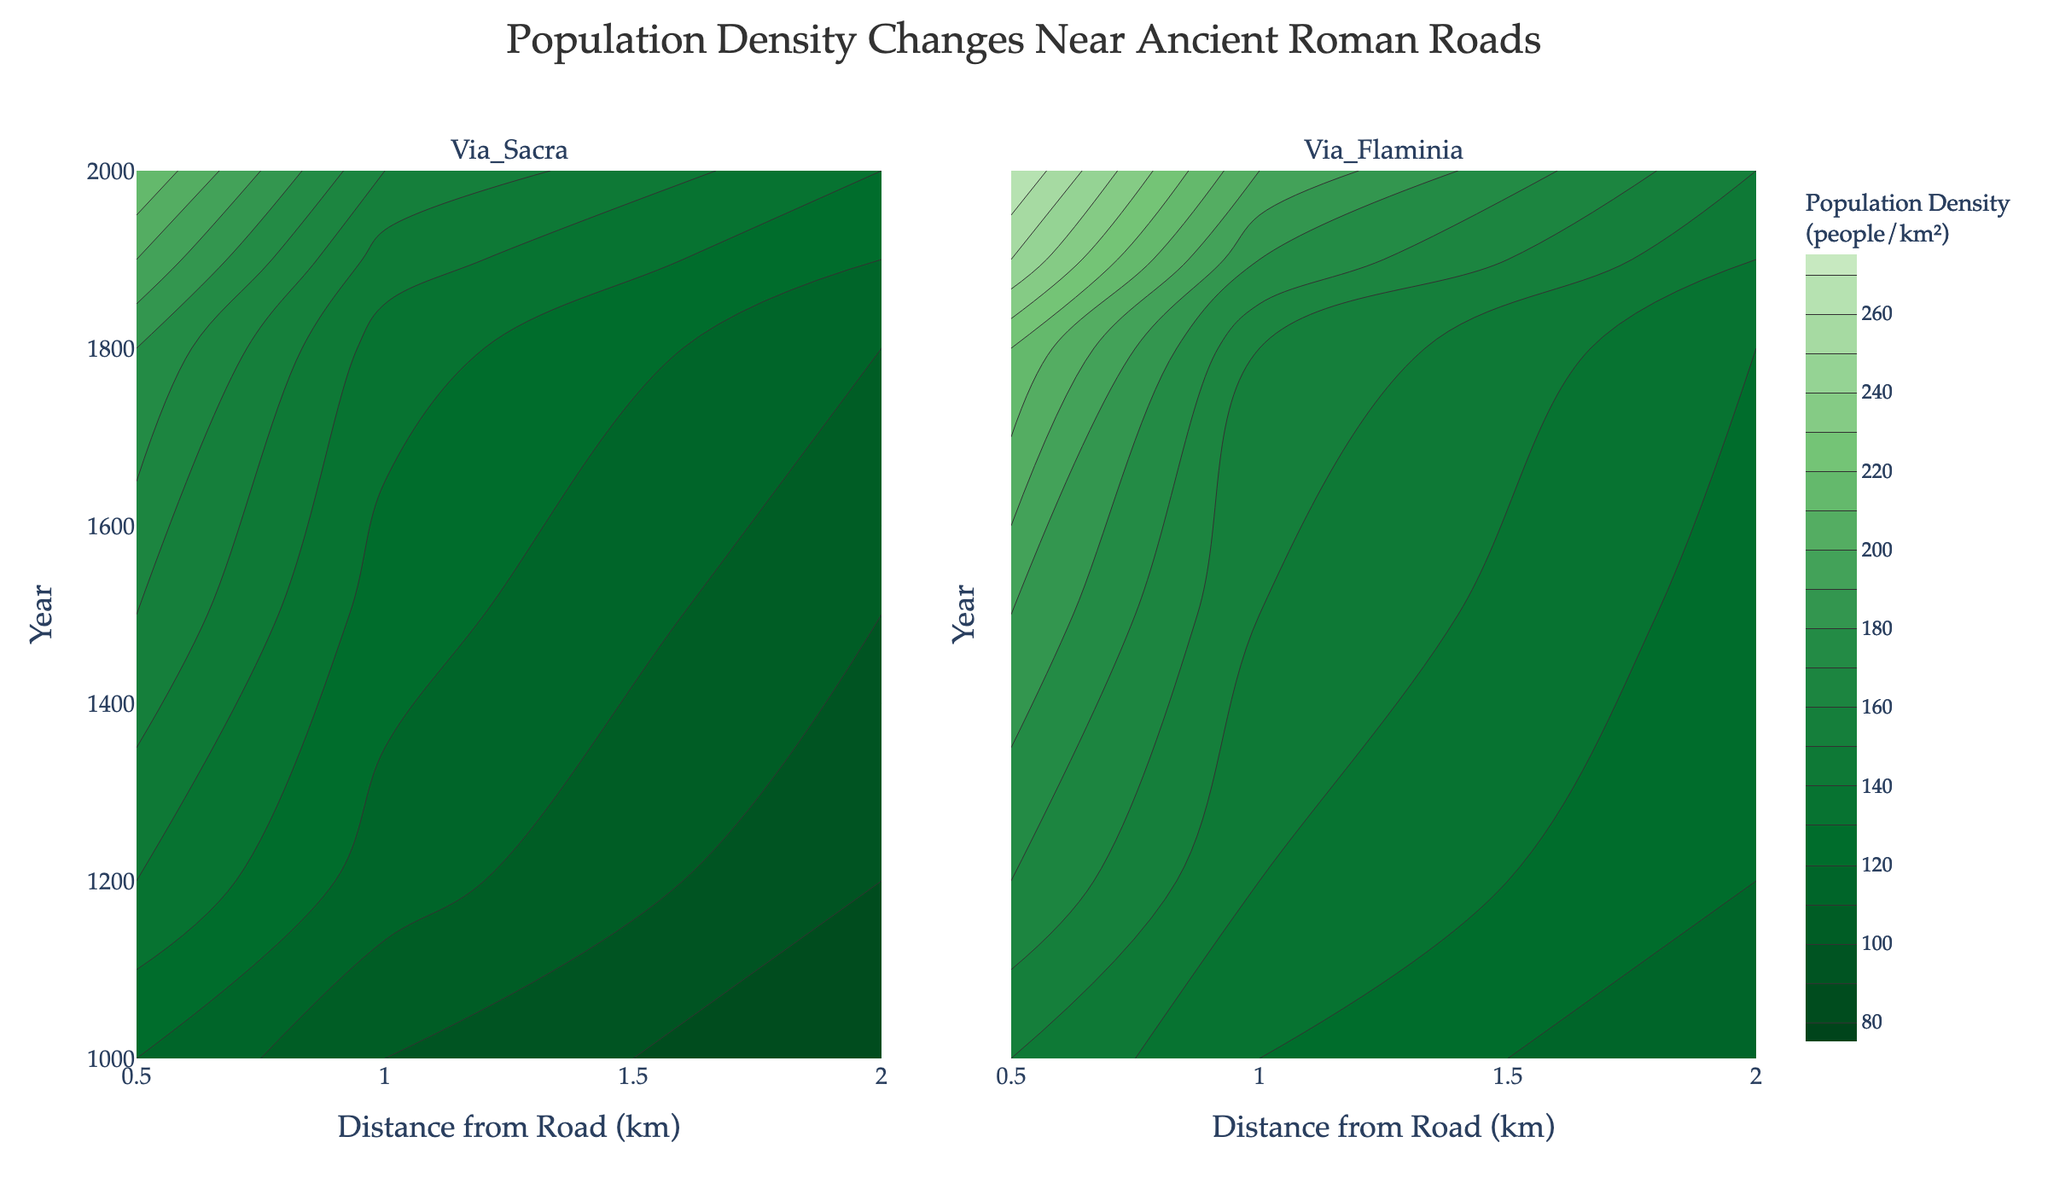what is the title of the plot? The title of the plot is typically located at the top center. In this case, it is "Population Density Changes Near Ancient Roman Roads."
Answer: Population Density Changes Near Ancient Roman Roads what ranges of population density are represented by the contour lines? The contour lines represent population densities from 80 to 270 people/km². This is indicated by the contour settings which start at 80, end at 270, and have a size of 10.
Answer: 80 to 270 people/km² what is the impact of distance from the road on population density in the year 2000 along Via Sacra and Via Flaminia? For Via Sacra, density decreases from 220 to 130 people/km² as distance increases from 0.5 to 2 km. For Via Flaminia, density decreases from 270 to 150 people/km². This pattern is visible by following the contour lines for the year 2000.
Answer: Decreases for both roads which road had the higher overall population density in the year 1500? To compare the overall population densities, we look at the contour lines for the year 1500. Via Flaminia shows higher densities with values from 125 to 190 people/km² compared to Via Sacra's 100 to 160 people/km².
Answer: Via Flaminia how did the population density change near Via Sacra from the year 1000 to 2000 for the closest distance of 0.5 km? In the year 1000, the density was 120 people/km². It increased over time, reaching 220 people/km² in 2000. This is visible by tracing the contour lines for 0.5 km from 1000 to 2000.
Answer: Increased from 120 to 220 people/km² what are the years chosen as y-axis ticks in the contour plot? The y-axis represents "Year" and typically includes ticks for selected years. Based on the provided data, the ticks might show years like 1000, 1200, 1500, 1800, 1900, 2000.
Answer: 1000, 1200, 1500, 1800, 1900, 2000 where is the highest population density found in proximity to Via Flaminia in the year 2000? The highest density for Via Flaminia in 2000 is found at the closest distance of 0.5 km, with a value of 270 people/km². This can be observed by locating the 270 contour line at this distance and year.
Answer: 0.5 km with 270 people/km² how does the population density at 1 km from Via Sacra compare to 1 km from Via Flaminia in 1200? In 1200, the density at 1 km from Via Sacra is 115 people/km², while it is 140 people/km² for Via Flaminia. By focusing on the contour lines at the 1 km distance for that year, we can observe these values.
Answer: Via Flaminia is higher by 25 people/km² how can one identify the trends in population density over the centuries near the ancient roads? Look for patterns in the contour lines across the years. Densities generally increase over time for both roads, which can be seen as contour lines representing higher densities spread further across later years.
Answer: Increasing over time 